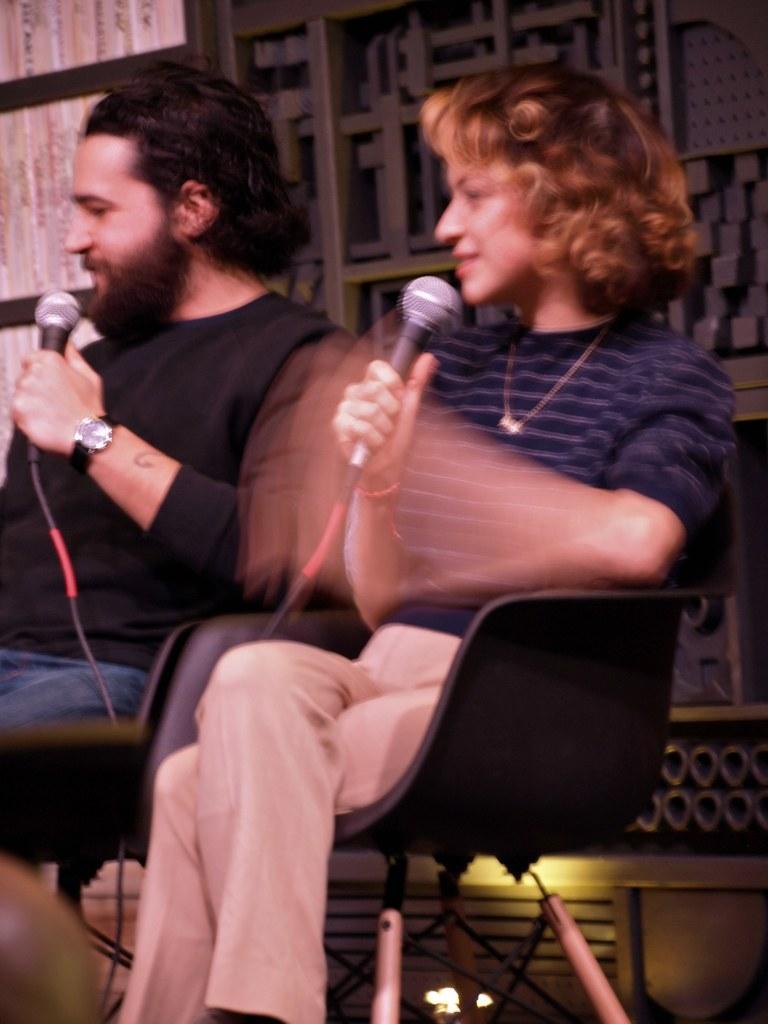Could you give a brief overview of what you see in this image? In this picture there is a woman wearing blue color t- shirt sitting on the chair and holding microphone in the hand. Beside there is a boy wearing black color t- shirt is sitting on the chair. In the background there is a big wooden rack. 